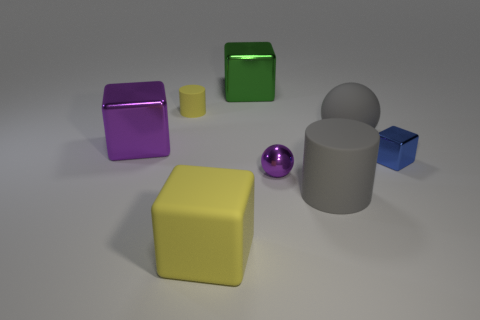Subtract all metal cubes. How many cubes are left? 1 Add 1 cyan metallic cylinders. How many objects exist? 9 Subtract all yellow blocks. How many blocks are left? 3 Subtract all big blocks. Subtract all big yellow rubber blocks. How many objects are left? 4 Add 5 yellow things. How many yellow things are left? 7 Add 3 large purple metallic blocks. How many large purple metallic blocks exist? 4 Subtract 0 purple cylinders. How many objects are left? 8 Subtract 1 balls. How many balls are left? 1 Subtract all red cubes. Subtract all yellow cylinders. How many cubes are left? 4 